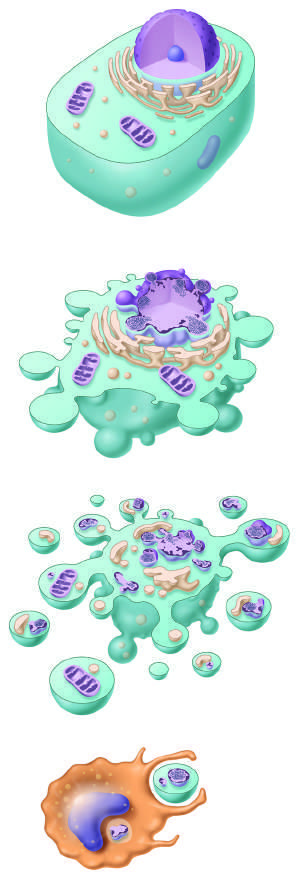what are illustrated?
Answer the question using a single word or phrase. The cellular alterations in apoptosis are illustrated 